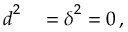Convert formula to latex. <formula><loc_0><loc_0><loc_500><loc_500>\begin{array} { r l } { d ^ { 2 } } & = \delta ^ { 2 } = 0 \, , } \end{array}</formula> 